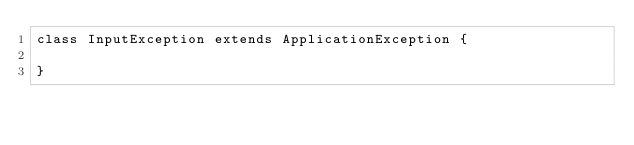Convert code to text. <code><loc_0><loc_0><loc_500><loc_500><_PHP_>class InputException extends ApplicationException {
	
}</code> 